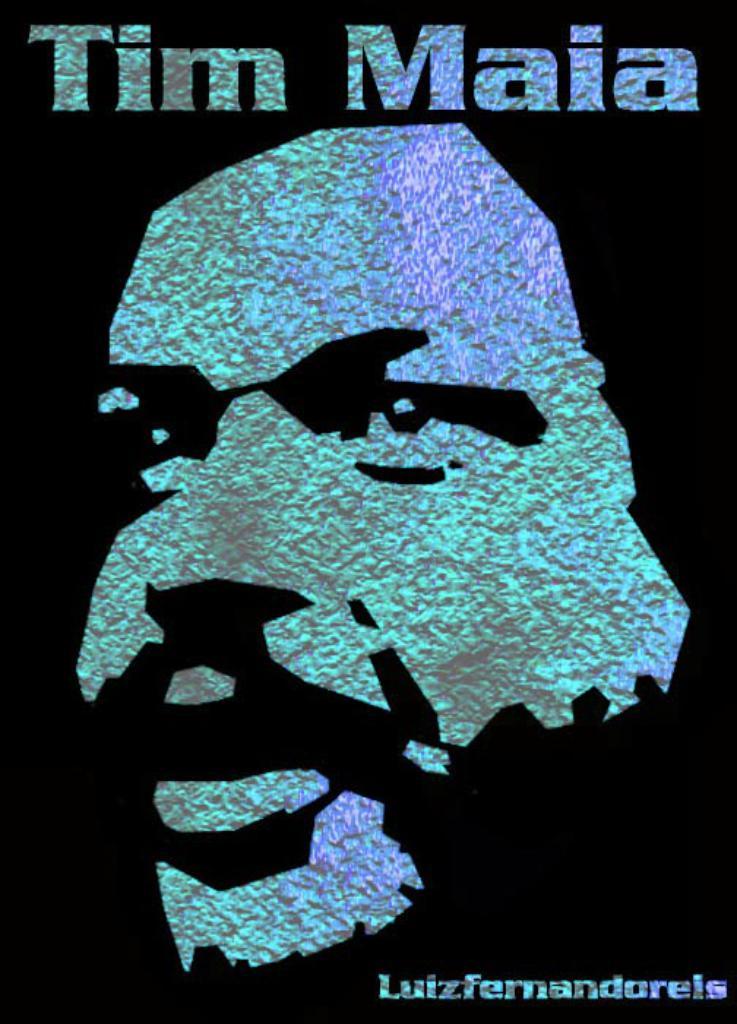What is tim's last name?
Provide a succinct answer. Maia. What website is on the bottom right corner?
Your answer should be compact. Unanswerable. 